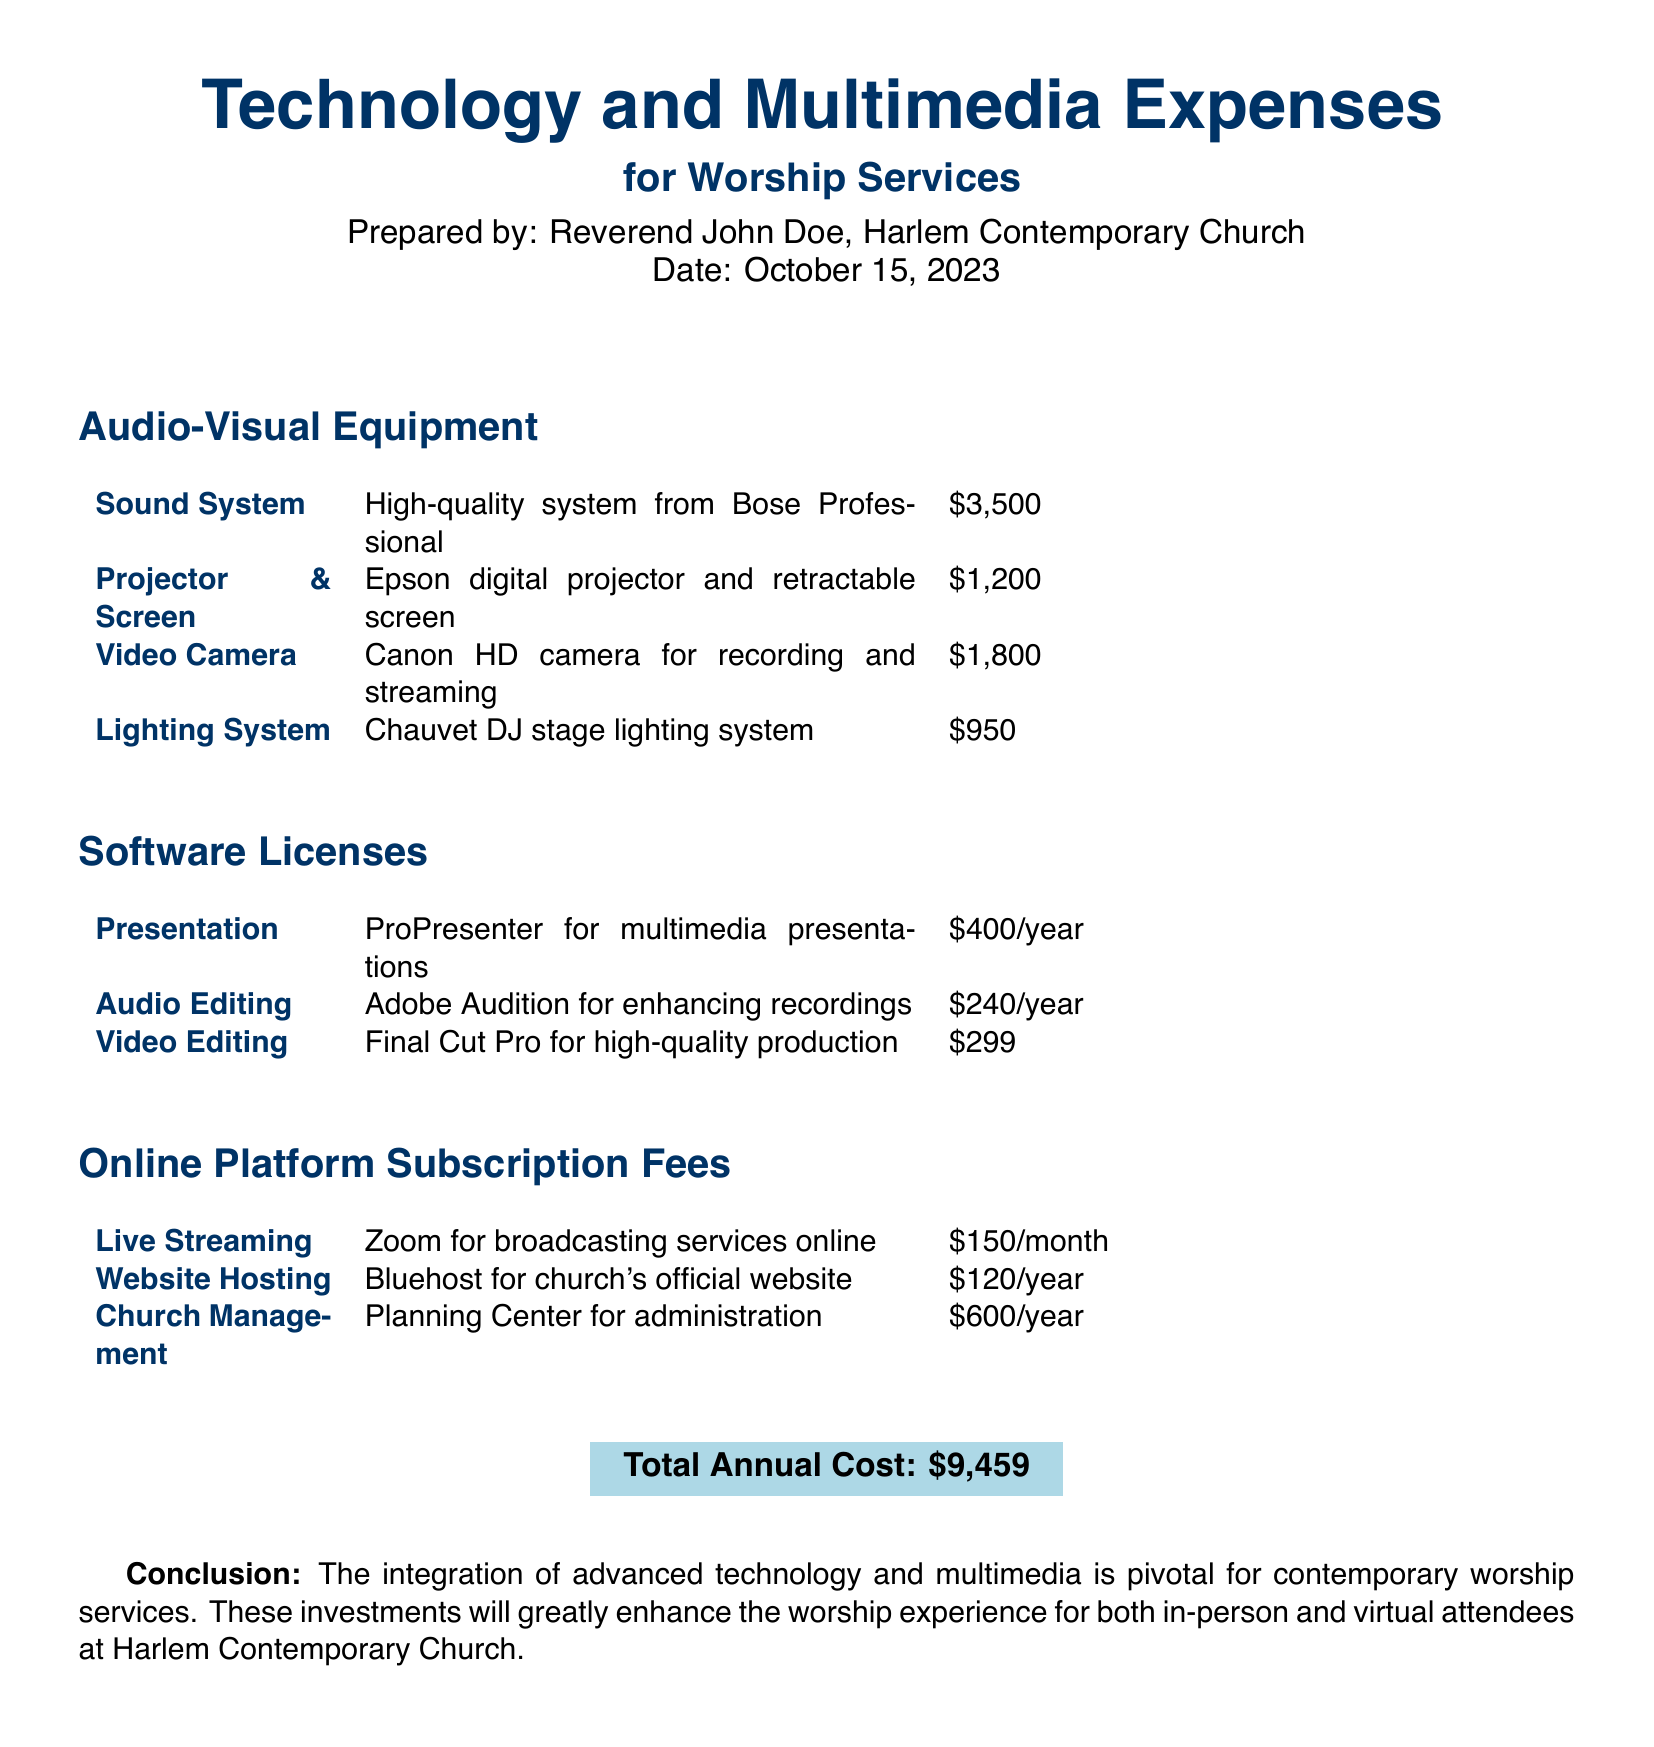What is the total annual cost? The total annual cost is highlighted at the bottom of the document and is the sum of all expenses listed.
Answer: $9,459 What is the cost of the sound system? The document lists the sound system under Audio-Visual Equipment with its corresponding cost.
Answer: $3,500 What software is used for multimedia presentations? The specific software for multimedia presentations is mentioned under Software Licenses.
Answer: ProPresenter How much is the Zoom subscription fee? The monthly fee for Zoom is stated under Online Platform Subscription Fees.
Answer: $150/month Which company provides the lighting system? The document specifies the brand of the lighting system in the Audio-Visual Equipment section.
Answer: Chauvet DJ What is the annual cost for Adobe Audition? The annual license cost for Adobe Audition is detailed in the Software Licenses section.
Answer: $240/year How many audio-visual equipment items are listed? The count of items listed under Audio-Visual Equipment can be summed up from the table in the document.
Answer: 4 Which platform is used for church management? The specific platform for church management is named in the Online Platform Subscription Fees section.
Answer: Planning Center What year was this expense report prepared? The date of preparation is mentioned prominently at the beginning of the document.
Answer: 2023 